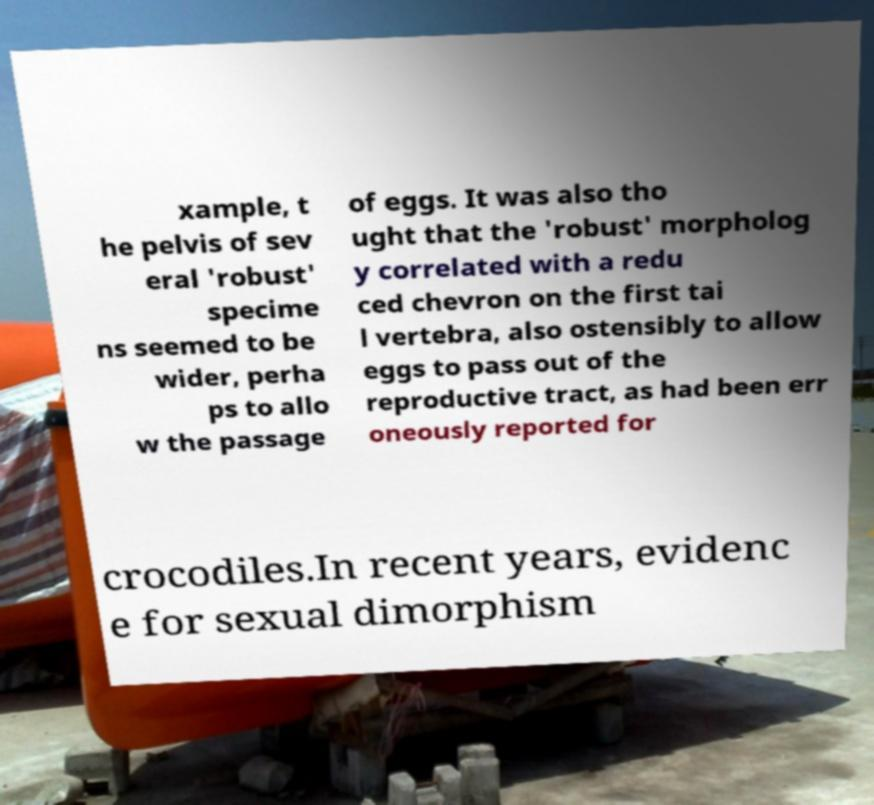Could you assist in decoding the text presented in this image and type it out clearly? xample, t he pelvis of sev eral 'robust' specime ns seemed to be wider, perha ps to allo w the passage of eggs. It was also tho ught that the 'robust' morpholog y correlated with a redu ced chevron on the first tai l vertebra, also ostensibly to allow eggs to pass out of the reproductive tract, as had been err oneously reported for crocodiles.In recent years, evidenc e for sexual dimorphism 